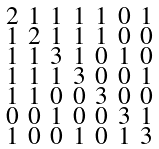Convert formula to latex. <formula><loc_0><loc_0><loc_500><loc_500>\begin{smallmatrix} 2 & 1 & 1 & 1 & 1 & 0 & 1 \\ 1 & 2 & 1 & 1 & 1 & 0 & 0 \\ 1 & 1 & 3 & 1 & 0 & 1 & 0 \\ 1 & 1 & 1 & 3 & 0 & 0 & 1 \\ 1 & 1 & 0 & 0 & 3 & 0 & 0 \\ 0 & 0 & 1 & 0 & 0 & 3 & 1 \\ 1 & 0 & 0 & 1 & 0 & 1 & 3 \end{smallmatrix}</formula> 